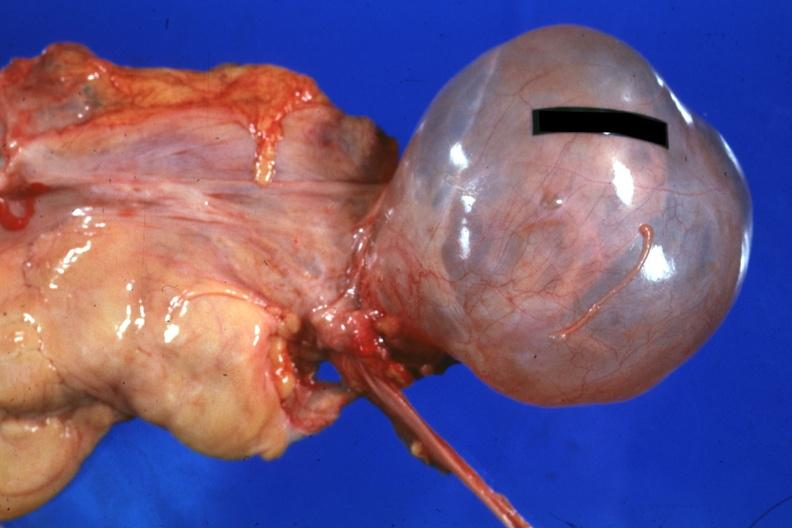s female reproductive present?
Answer the question using a single word or phrase. Yes 